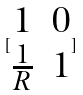<formula> <loc_0><loc_0><loc_500><loc_500>[ \begin{matrix} 1 & 0 \\ \frac { 1 } { R } & 1 \end{matrix} ]</formula> 